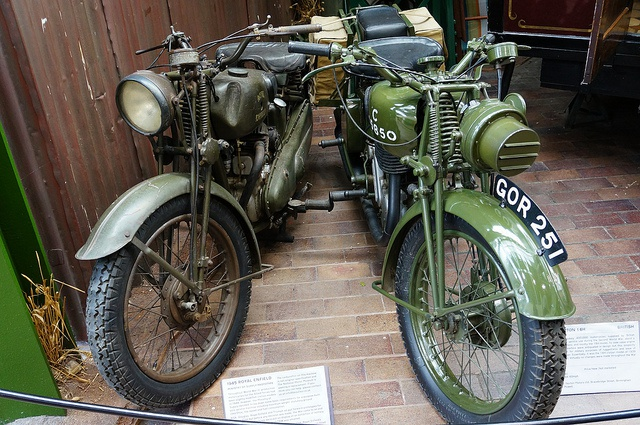Describe the objects in this image and their specific colors. I can see motorcycle in black, gray, darkgray, and olive tones and motorcycle in black, gray, and darkgray tones in this image. 